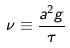<formula> <loc_0><loc_0><loc_500><loc_500>\nu \equiv \frac { a ^ { 2 } g } { \tau }</formula> 